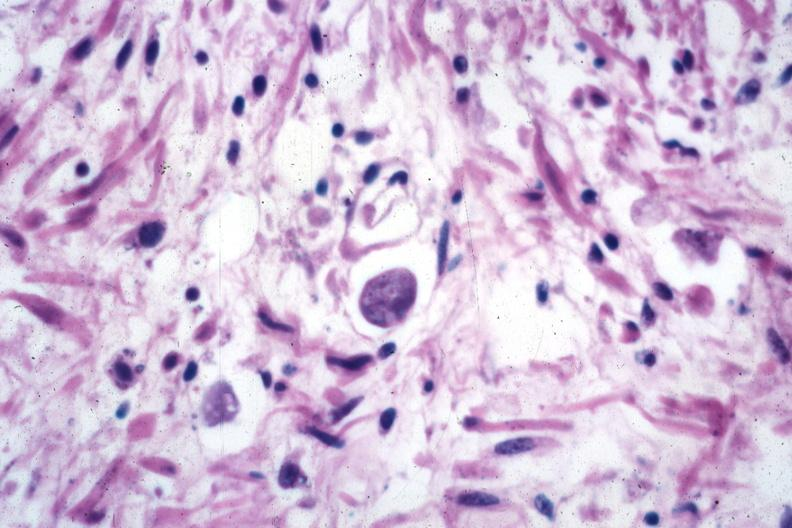what is present?
Answer the question using a single word or phrase. Amebiasis 